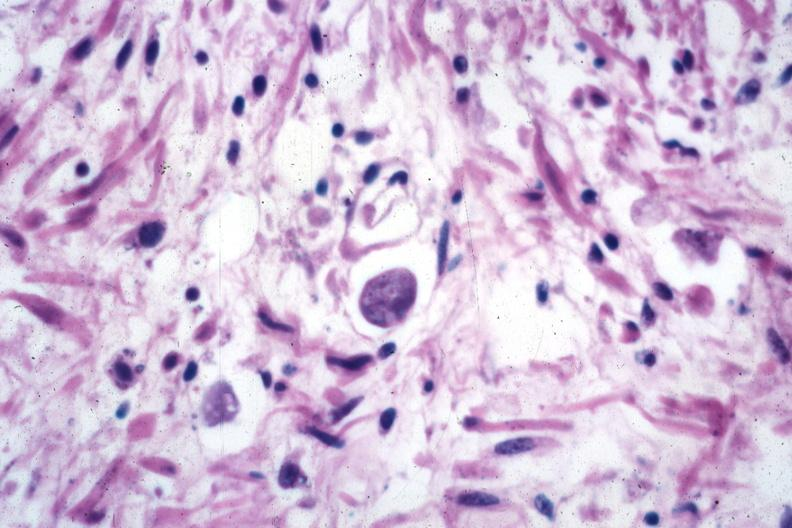what is present?
Answer the question using a single word or phrase. Amebiasis 